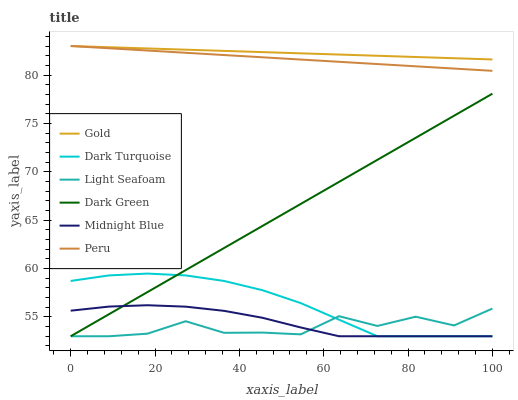Does Light Seafoam have the minimum area under the curve?
Answer yes or no. Yes. Does Gold have the maximum area under the curve?
Answer yes or no. Yes. Does Dark Turquoise have the minimum area under the curve?
Answer yes or no. No. Does Dark Turquoise have the maximum area under the curve?
Answer yes or no. No. Is Gold the smoothest?
Answer yes or no. Yes. Is Light Seafoam the roughest?
Answer yes or no. Yes. Is Dark Turquoise the smoothest?
Answer yes or no. No. Is Dark Turquoise the roughest?
Answer yes or no. No. Does Midnight Blue have the lowest value?
Answer yes or no. Yes. Does Gold have the lowest value?
Answer yes or no. No. Does Peru have the highest value?
Answer yes or no. Yes. Does Dark Turquoise have the highest value?
Answer yes or no. No. Is Dark Turquoise less than Gold?
Answer yes or no. Yes. Is Peru greater than Dark Green?
Answer yes or no. Yes. Does Dark Turquoise intersect Light Seafoam?
Answer yes or no. Yes. Is Dark Turquoise less than Light Seafoam?
Answer yes or no. No. Is Dark Turquoise greater than Light Seafoam?
Answer yes or no. No. Does Dark Turquoise intersect Gold?
Answer yes or no. No. 